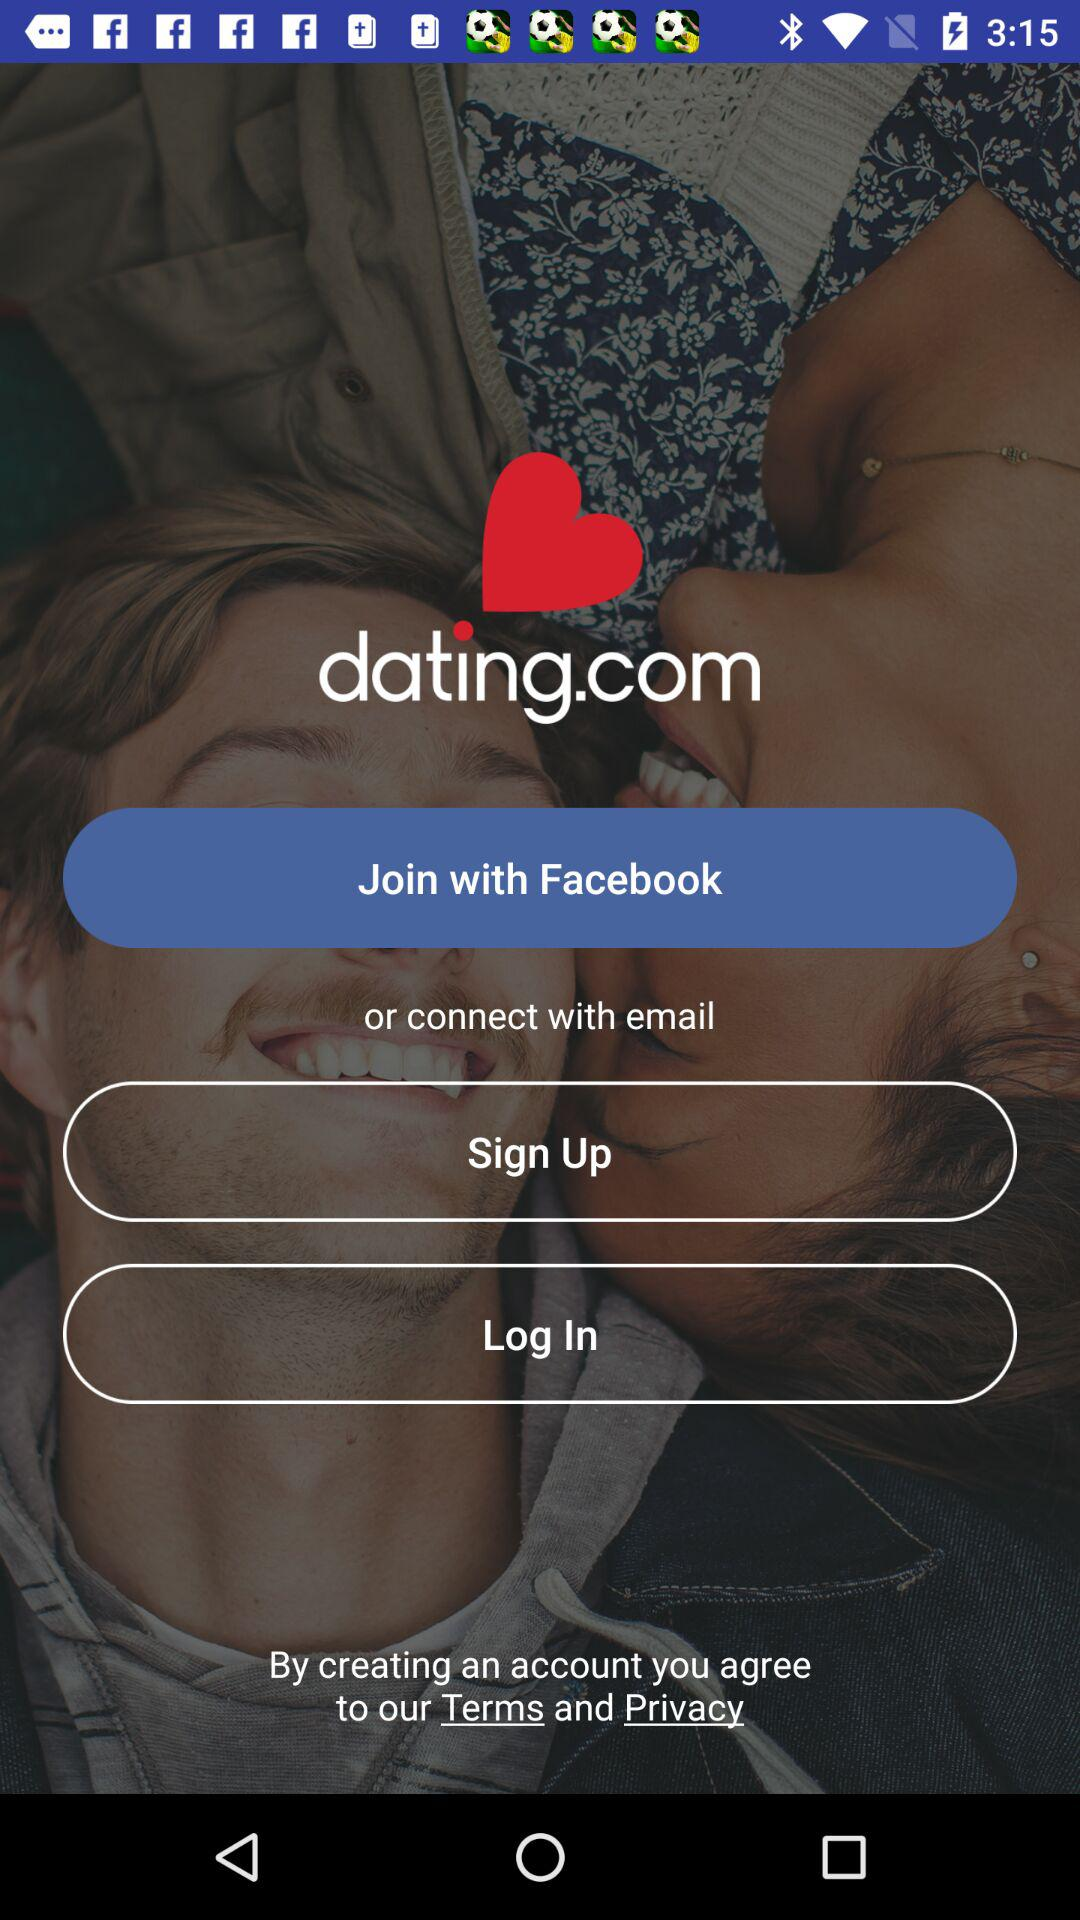Who is signing up or logging in?
When the provided information is insufficient, respond with <no answer>. <no answer> 